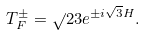<formula> <loc_0><loc_0><loc_500><loc_500>T _ { F } ^ { \pm } = \sqrt { } { 2 } 3 e ^ { \pm i \sqrt { 3 } H } .</formula> 